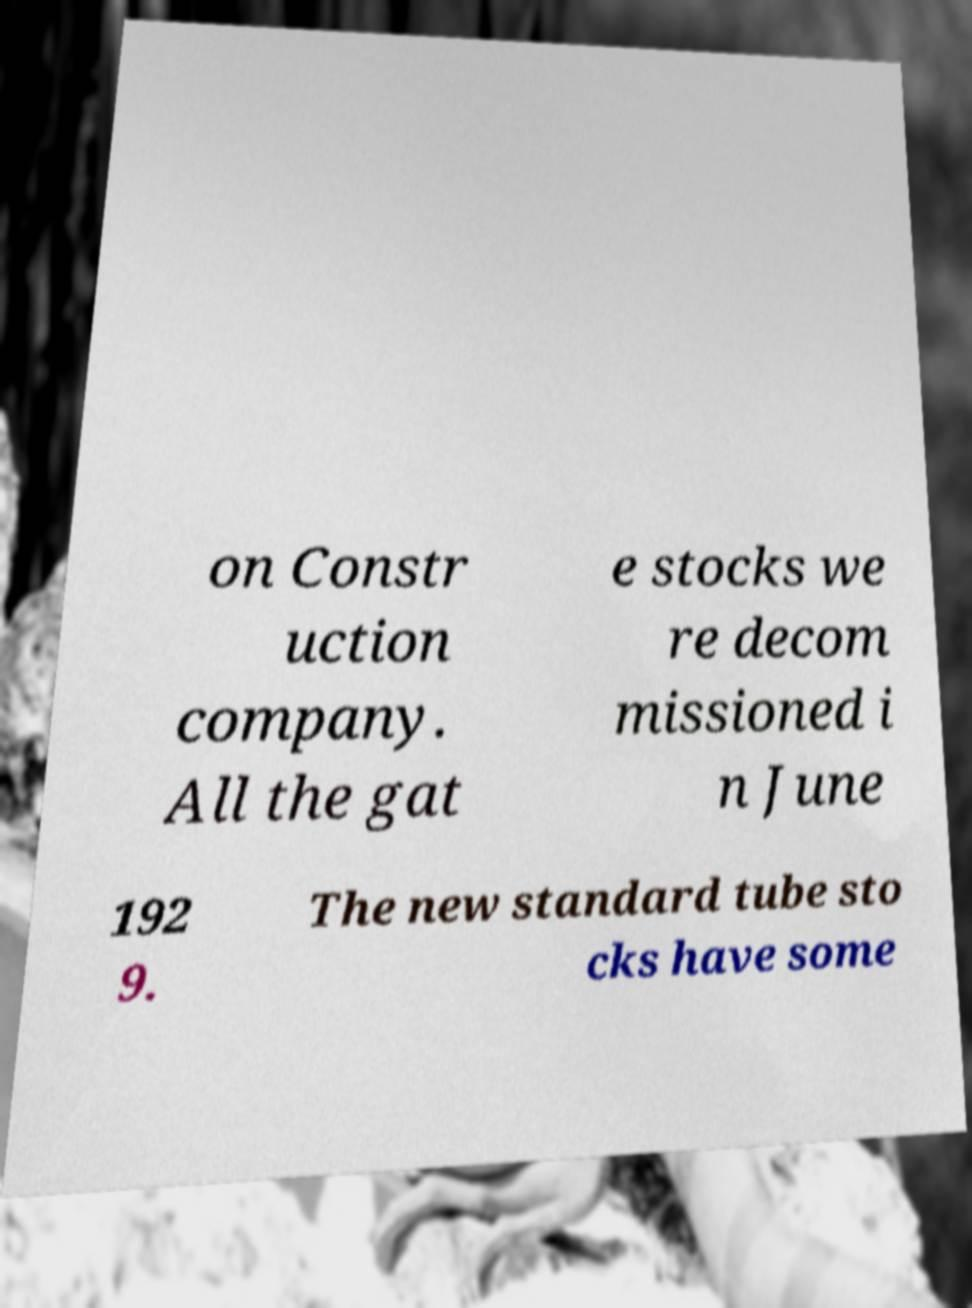What messages or text are displayed in this image? I need them in a readable, typed format. on Constr uction company. All the gat e stocks we re decom missioned i n June 192 9. The new standard tube sto cks have some 